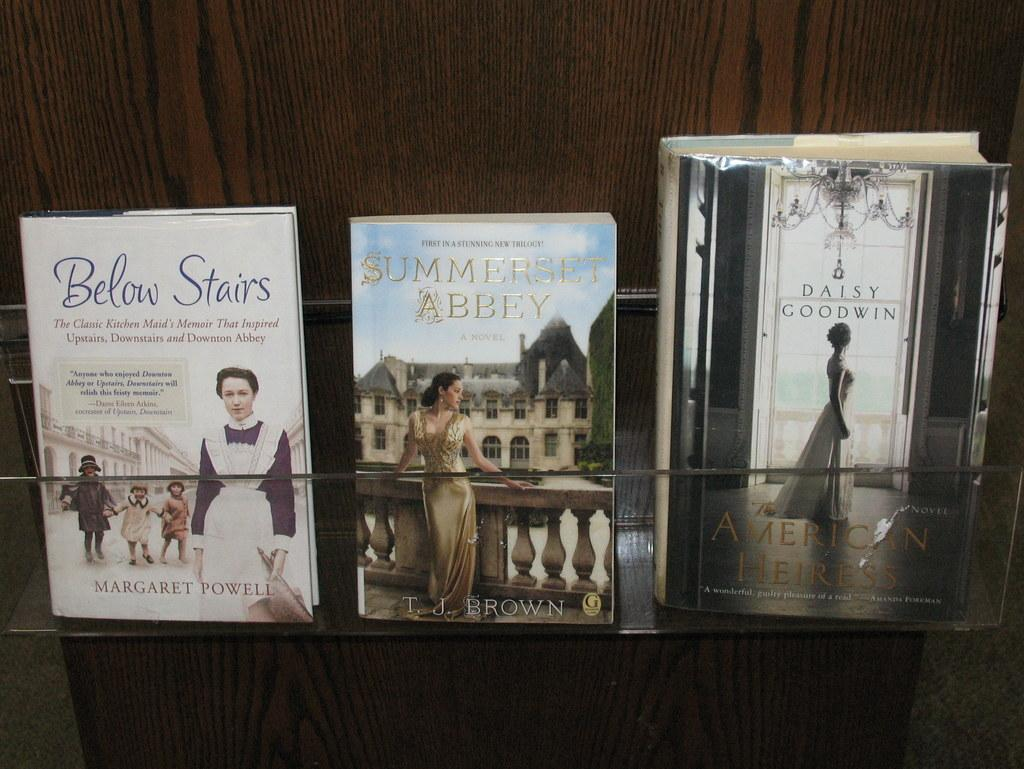What type of objects are labeled with names in the image? There are books with names in the image. How are the books arranged in the image? The books are placed on a wooden rack. What can be seen below the wooden rack in the image? The floor is visible in the image. What type of shoe is being twisted in the image? There is no shoe present in the image, nor is there any twisting action taking place. 